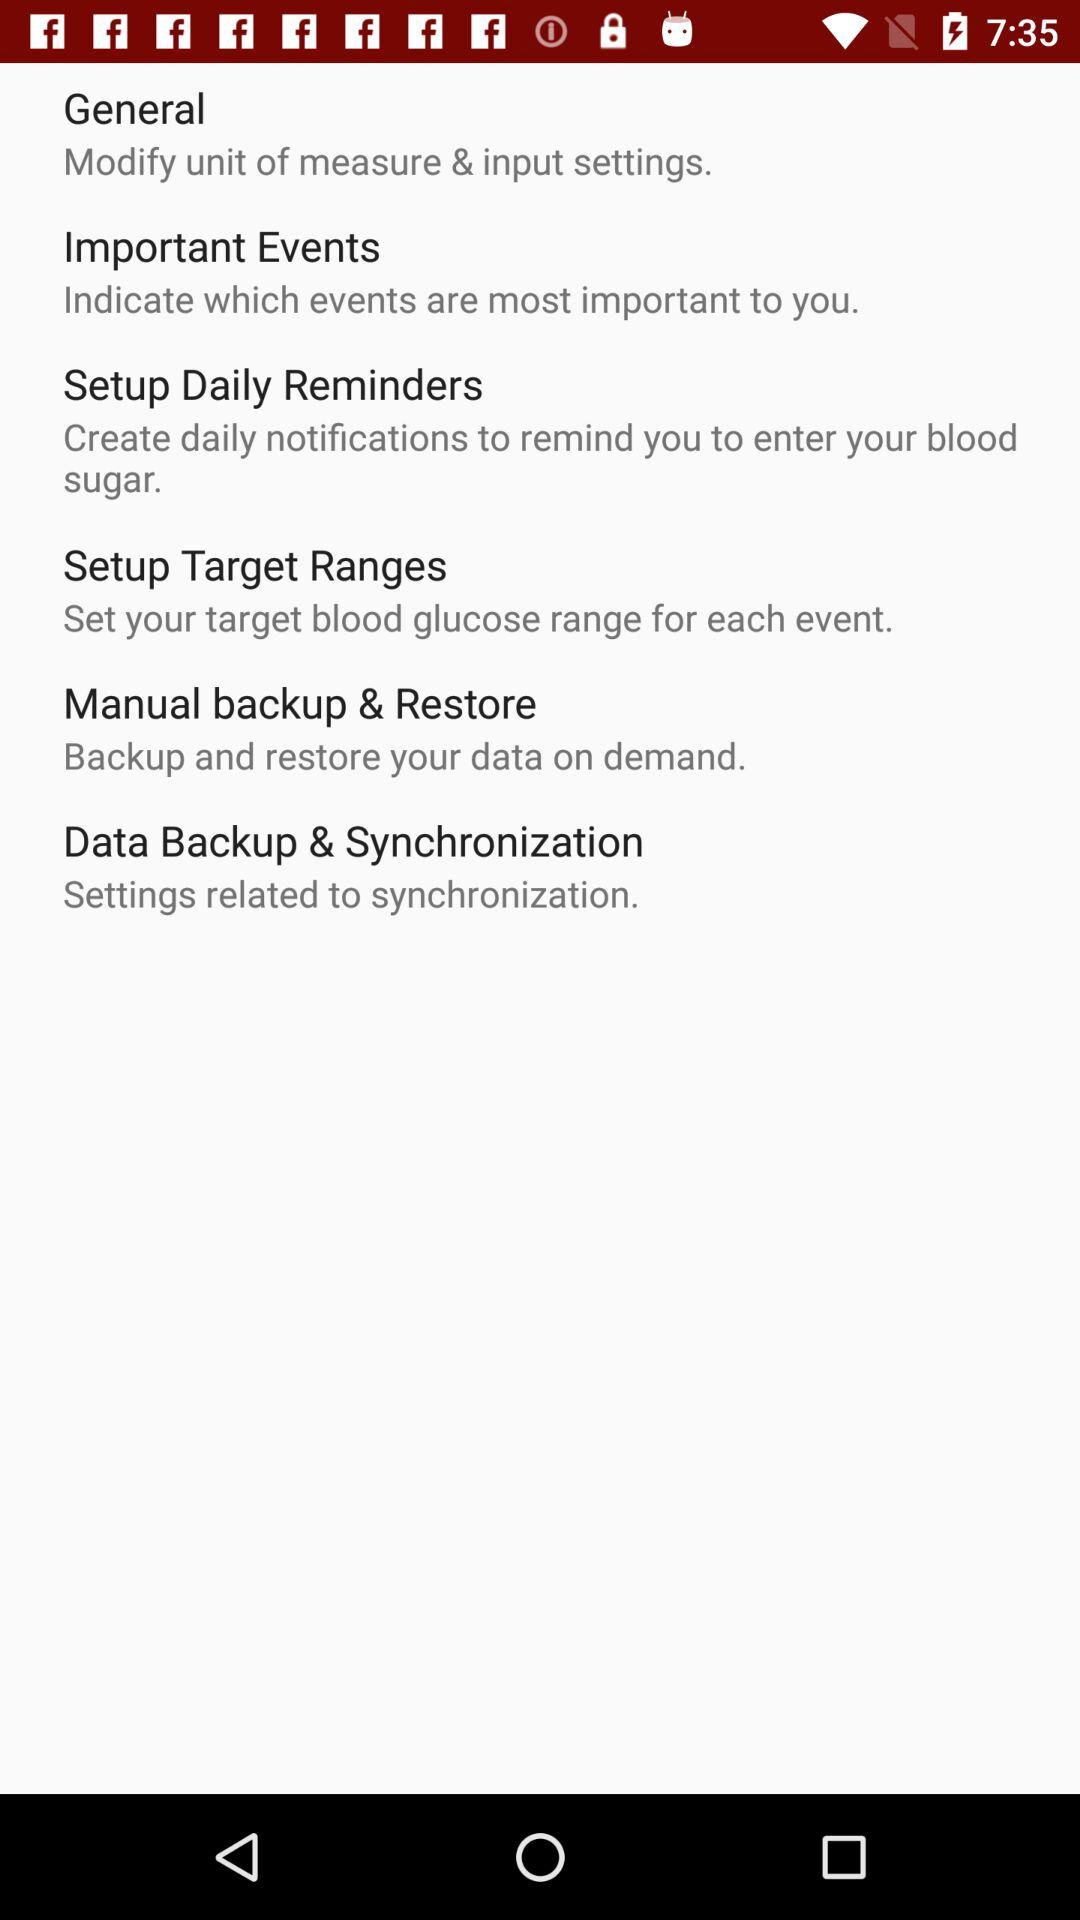How many items are in the settings menu?
Answer the question using a single word or phrase. 6 